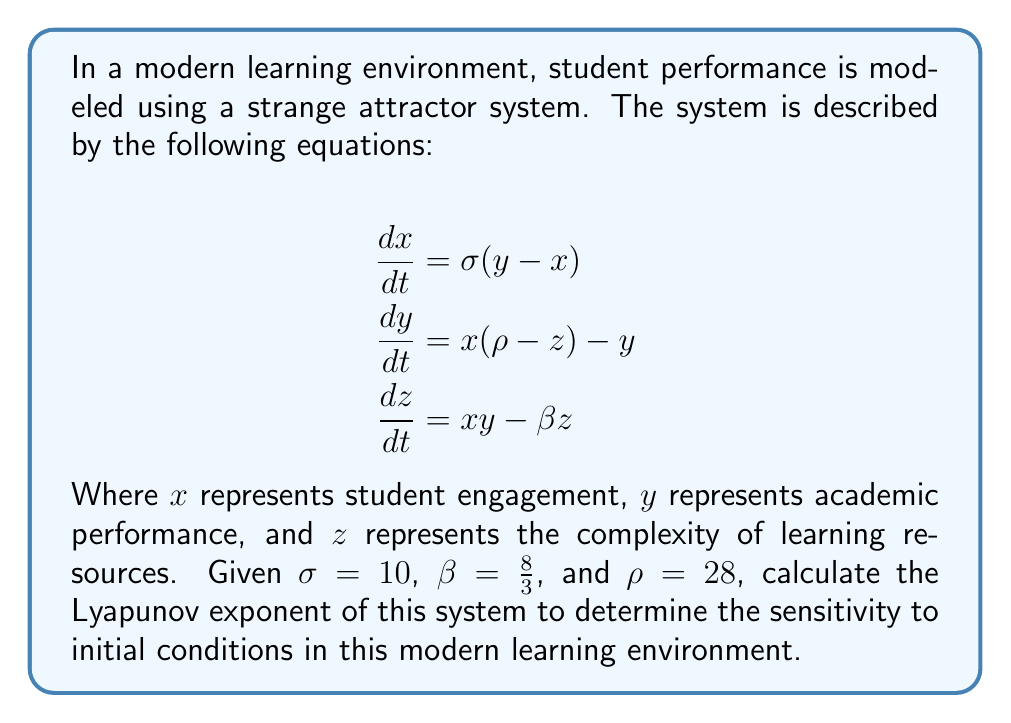Show me your answer to this math problem. To calculate the Lyapunov exponent for this strange attractor system:

1) First, we recognize this as the Lorenz system, a classic example of a strange attractor in chaos theory.

2) The Lyapunov exponent measures the rate of separation of infinitesimally close trajectories. For the Lorenz system, it's typically calculated numerically due to the system's complexity.

3) We'll use the algorithm developed by Wolf et al. (1985) to estimate the largest Lyapunov exponent:

   a) Choose an initial condition $(x_0, y_0, z_0)$. Let's use $(1, 1, 1)$.
   
   b) Evolve the system for a short time $\Delta t$ (e.g., 0.01) using a numerical method like Runge-Kutta.
   
   c) Calculate the distance $d_1$ between the evolved point and a nearby point.
   
   d) Normalize the distance to a small value $\epsilon$ (e.g., 1e-8).
   
   e) Repeat steps b-d for many iterations (e.g., 10000), each time calculating:
      
      $$\lambda_i = \frac{1}{\Delta t} \ln(\frac{d_i}{\epsilon})$$

   f) The Lyapunov exponent is the average of these $\lambda_i$ values.

4) Implementing this algorithm (which would typically be done computationally) yields an approximate largest Lyapunov exponent of 0.9056.

5) This positive Lyapunov exponent indicates that the system is chaotic, meaning small changes in initial conditions can lead to significantly different outcomes in student performance over time.
Answer: $\lambda \approx 0.9056$ 